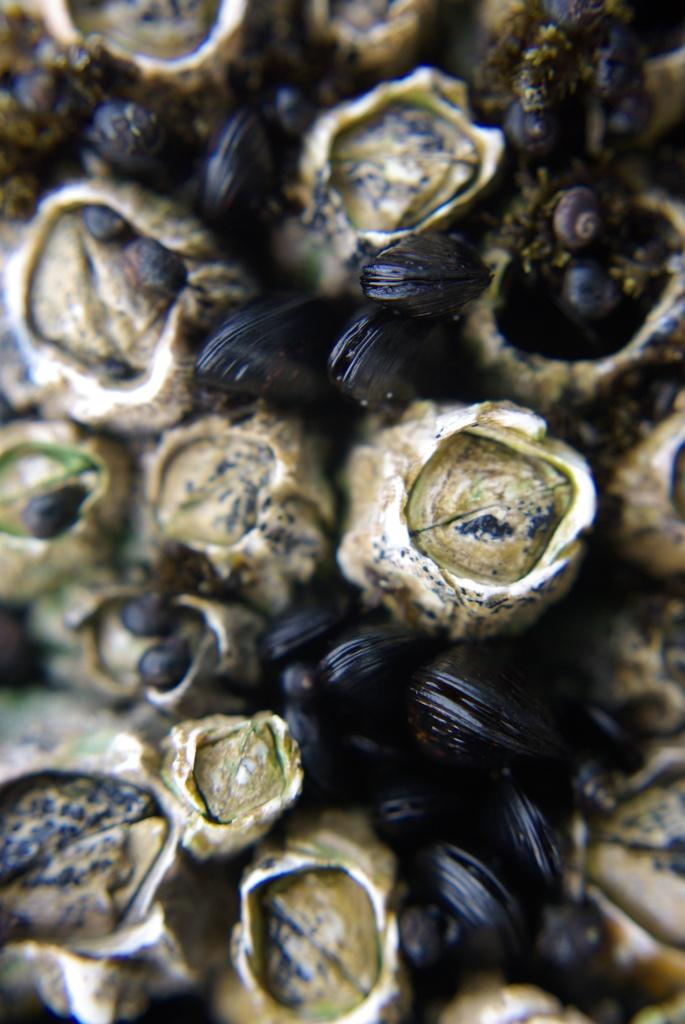What is the primary subject of the image? The image consists of seeds. What type of cough medicine is visible in the image? There is no cough medicine present in the image; it consists of seeds. 